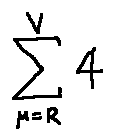Convert formula to latex. <formula><loc_0><loc_0><loc_500><loc_500>\sum \lim i t s _ { \mu = R } ^ { V } 4</formula> 